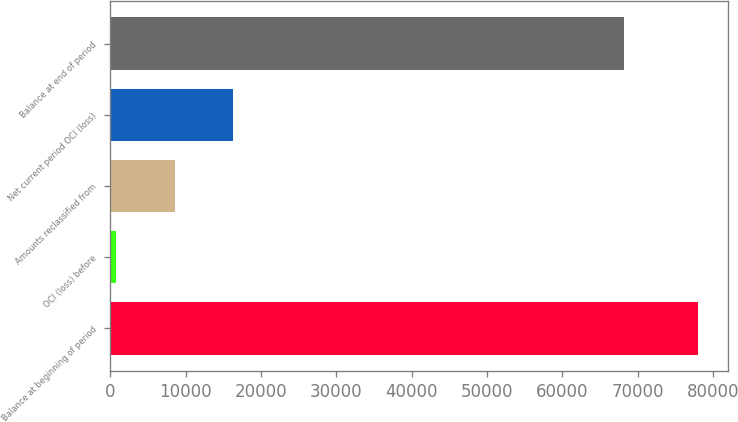Convert chart to OTSL. <chart><loc_0><loc_0><loc_500><loc_500><bar_chart><fcel>Balance at beginning of period<fcel>OCI (loss) before<fcel>Amounts reclassified from<fcel>Net current period OCI (loss)<fcel>Balance at end of period<nl><fcel>78053<fcel>810<fcel>8534.3<fcel>16258.6<fcel>68141<nl></chart> 